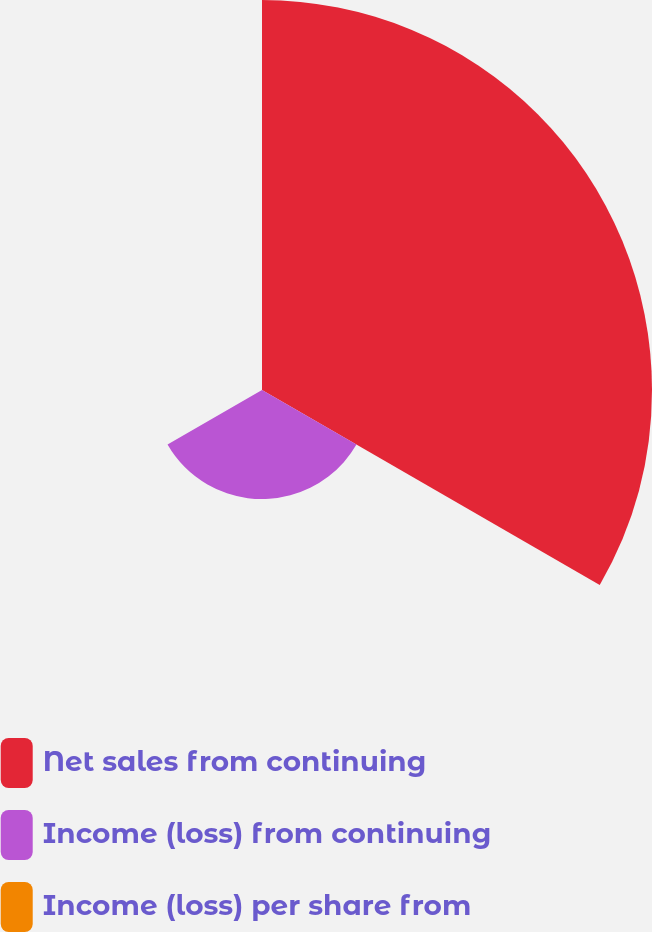<chart> <loc_0><loc_0><loc_500><loc_500><pie_chart><fcel>Net sales from continuing<fcel>Income (loss) from continuing<fcel>Income (loss) per share from<nl><fcel>78.12%<fcel>21.85%<fcel>0.04%<nl></chart> 